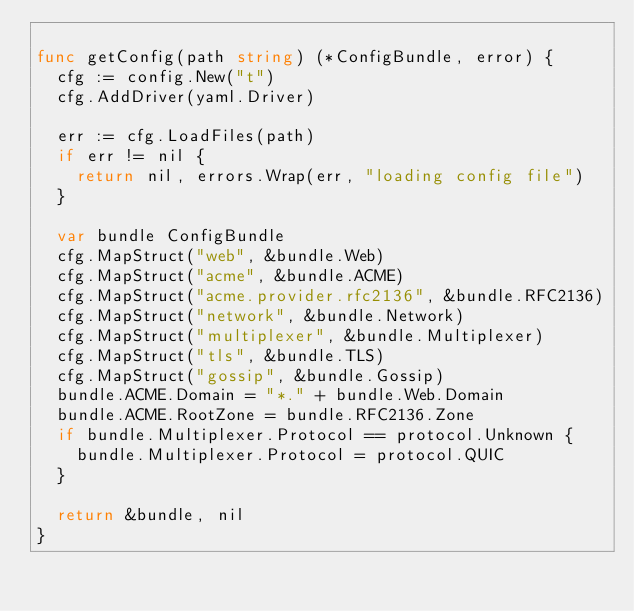Convert code to text. <code><loc_0><loc_0><loc_500><loc_500><_Go_>
func getConfig(path string) (*ConfigBundle, error) {
	cfg := config.New("t")
	cfg.AddDriver(yaml.Driver)

	err := cfg.LoadFiles(path)
	if err != nil {
		return nil, errors.Wrap(err, "loading config file")
	}

	var bundle ConfigBundle
	cfg.MapStruct("web", &bundle.Web)
	cfg.MapStruct("acme", &bundle.ACME)
	cfg.MapStruct("acme.provider.rfc2136", &bundle.RFC2136)
	cfg.MapStruct("network", &bundle.Network)
	cfg.MapStruct("multiplexer", &bundle.Multiplexer)
	cfg.MapStruct("tls", &bundle.TLS)
	cfg.MapStruct("gossip", &bundle.Gossip)
	bundle.ACME.Domain = "*." + bundle.Web.Domain
	bundle.ACME.RootZone = bundle.RFC2136.Zone
	if bundle.Multiplexer.Protocol == protocol.Unknown {
		bundle.Multiplexer.Protocol = protocol.QUIC
	}

	return &bundle, nil
}
</code> 